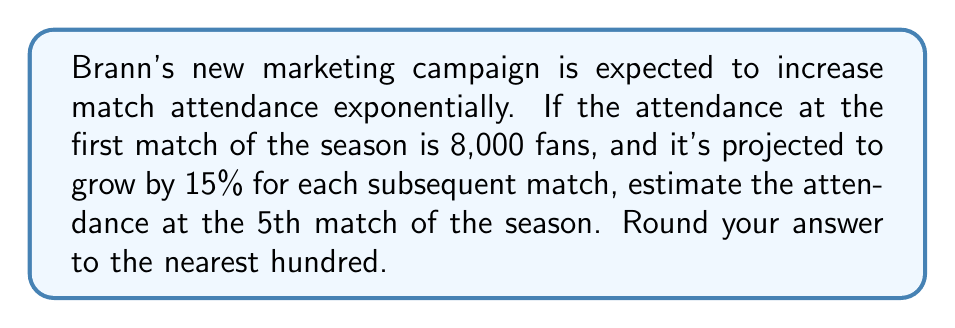Can you solve this math problem? Let's approach this step-by-step using an exponential growth function:

1) The general form of an exponential growth function is:
   $$A(t) = A_0 \cdot (1 + r)^t$$
   where $A(t)$ is the amount after time $t$, $A_0$ is the initial amount, and $r$ is the growth rate.

2) In this case:
   $A_0 = 8,000$ (initial attendance)
   $r = 0.15$ (15% growth rate)
   $t = 4$ (we want the 5th match, which is 4 matches after the first)

3) Plugging these values into our function:
   $$A(4) = 8,000 \cdot (1 + 0.15)^4$$

4) Simplify:
   $$A(4) = 8,000 \cdot (1.15)^4$$

5) Calculate:
   $$A(4) = 8,000 \cdot 1.74900625$$
   $$A(4) = 13,992.05$$

6) Rounding to the nearest hundred:
   $$A(4) \approx 14,000$$

Therefore, the estimated attendance at the 5th match would be approximately 14,000 fans.
Answer: 14,000 fans 